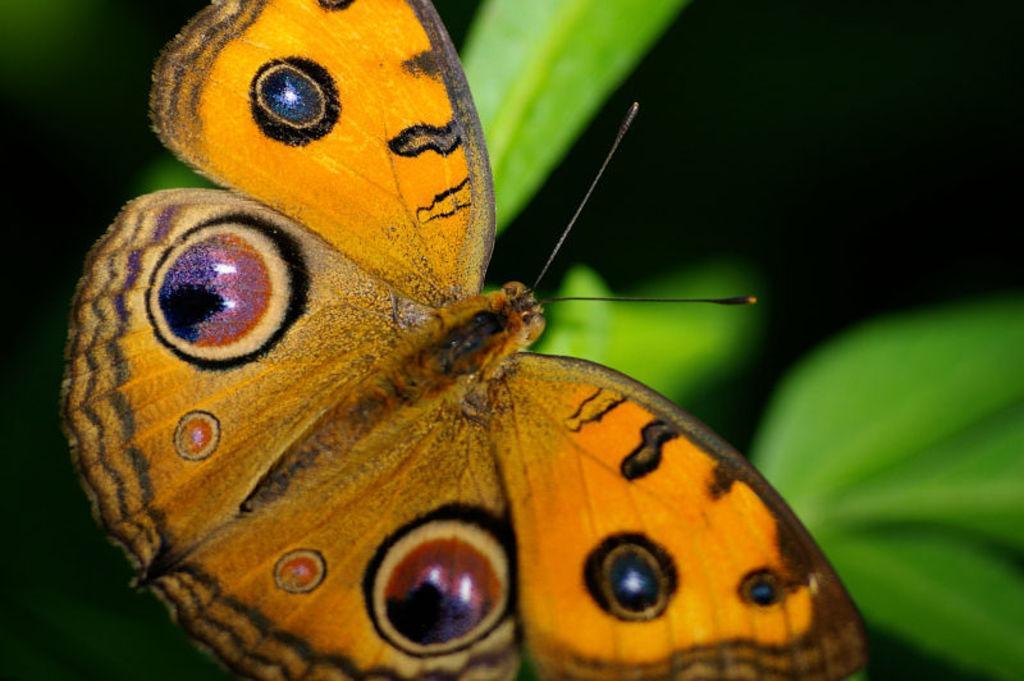Could you give a brief overview of what you see in this image? In this image there is a butterfly and there are leaves. 